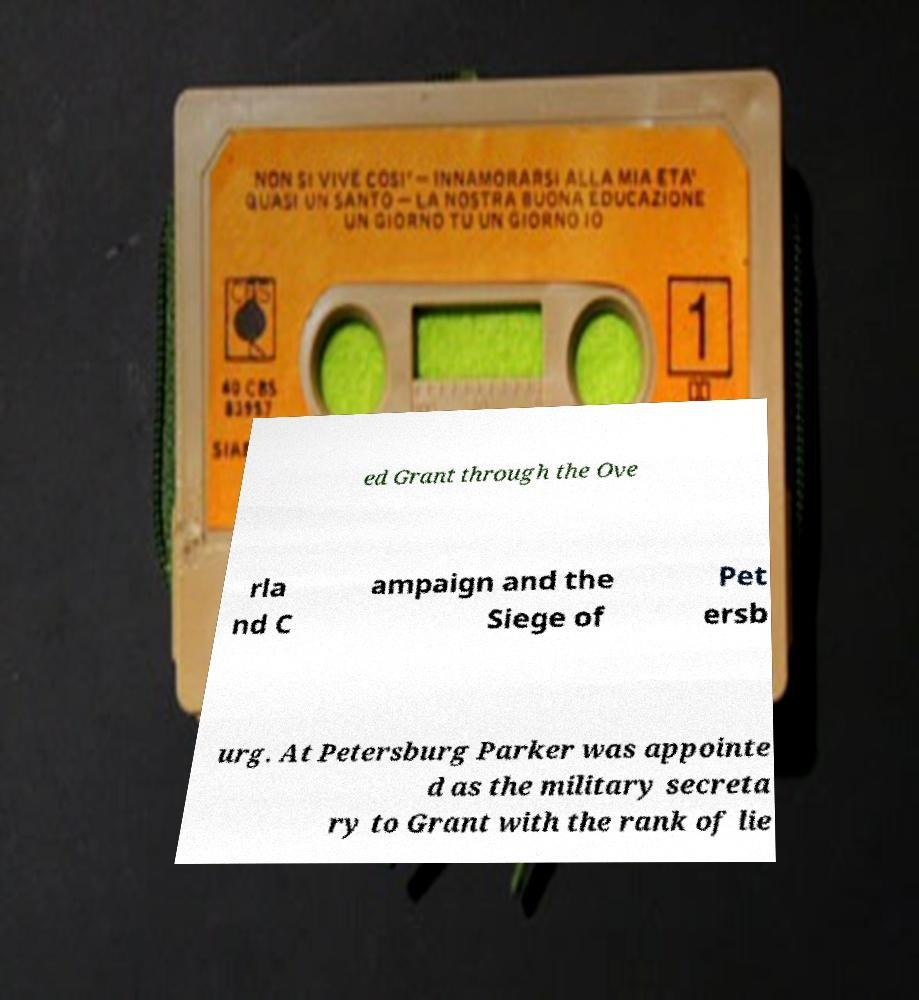Can you accurately transcribe the text from the provided image for me? ed Grant through the Ove rla nd C ampaign and the Siege of Pet ersb urg. At Petersburg Parker was appointe d as the military secreta ry to Grant with the rank of lie 